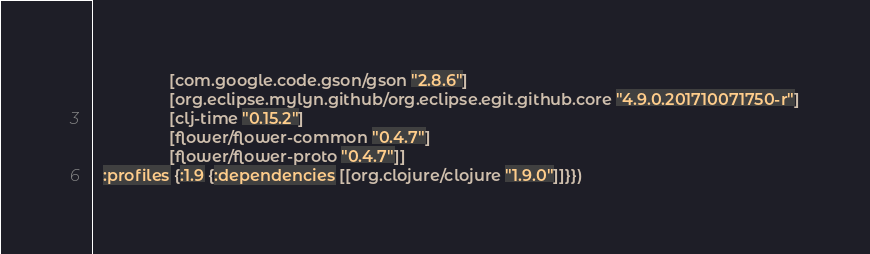Convert code to text. <code><loc_0><loc_0><loc_500><loc_500><_Clojure_>                 [com.google.code.gson/gson "2.8.6"]
                 [org.eclipse.mylyn.github/org.eclipse.egit.github.core "4.9.0.201710071750-r"]
                 [clj-time "0.15.2"]
                 [flower/flower-common "0.4.7"]
                 [flower/flower-proto "0.4.7"]]
  :profiles {:1.9 {:dependencies [[org.clojure/clojure "1.9.0"]]}})
</code> 